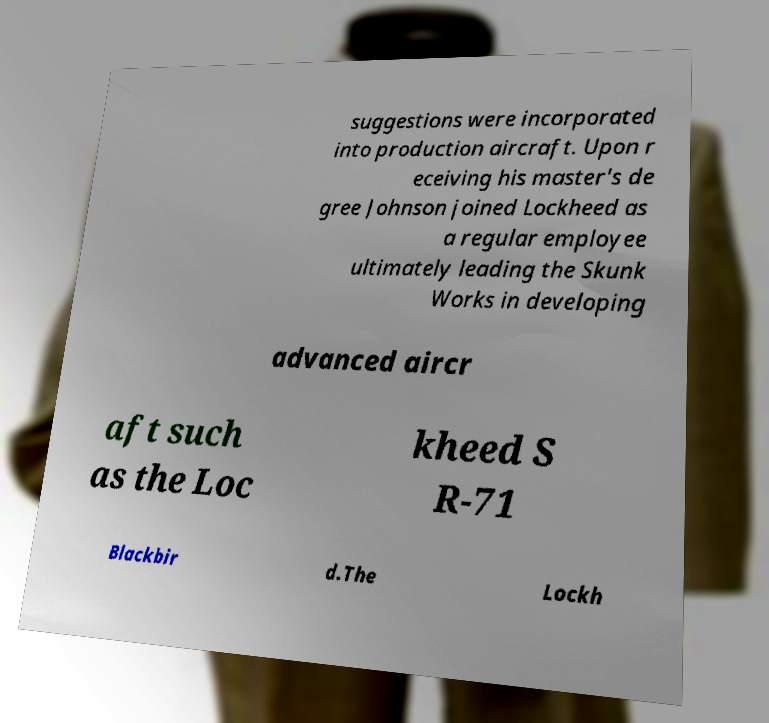Please read and relay the text visible in this image. What does it say? suggestions were incorporated into production aircraft. Upon r eceiving his master's de gree Johnson joined Lockheed as a regular employee ultimately leading the Skunk Works in developing advanced aircr aft such as the Loc kheed S R-71 Blackbir d.The Lockh 